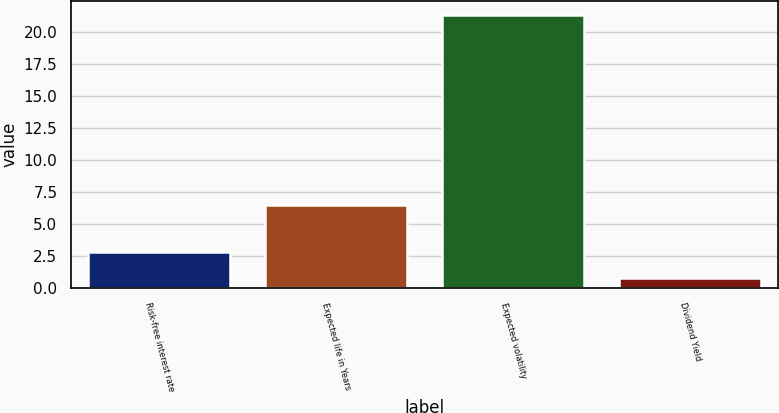Convert chart. <chart><loc_0><loc_0><loc_500><loc_500><bar_chart><fcel>Risk-free interest rate<fcel>Expected life in Years<fcel>Expected volatility<fcel>Dividend Yield<nl><fcel>2.86<fcel>6.5<fcel>21.4<fcel>0.8<nl></chart> 